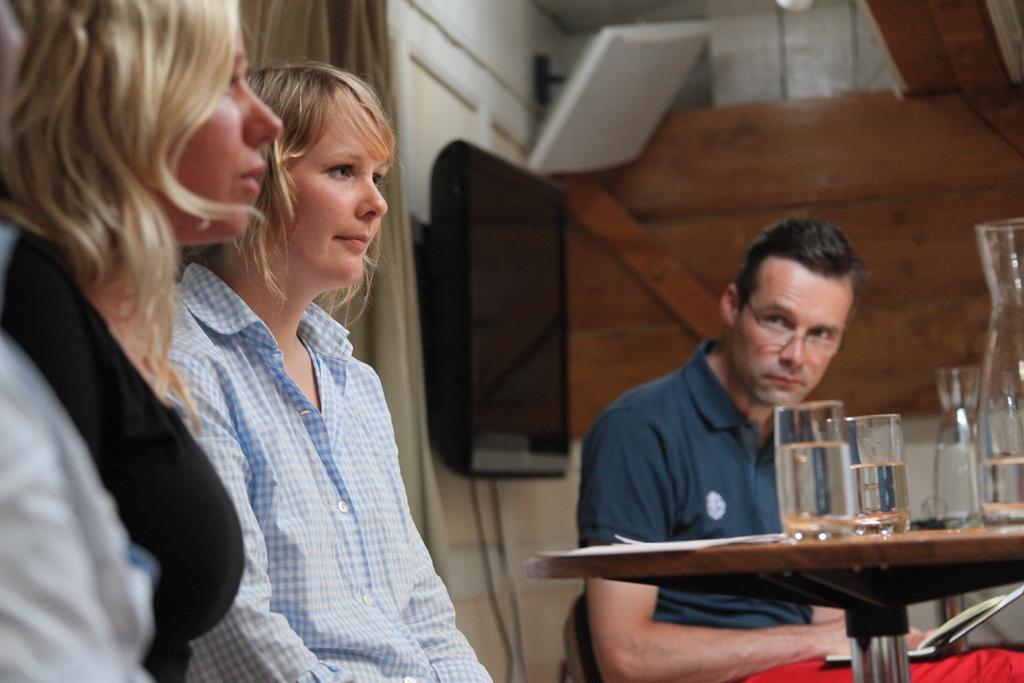In one or two sentences, can you explain what this image depicts? The three persons are sitting on a chairs. On the right side of the person is wearing a spectacle. He is holding a book. There is a table. There is a glasses ,paper on a table. We can see in the background TV,wires and wooden wall. 